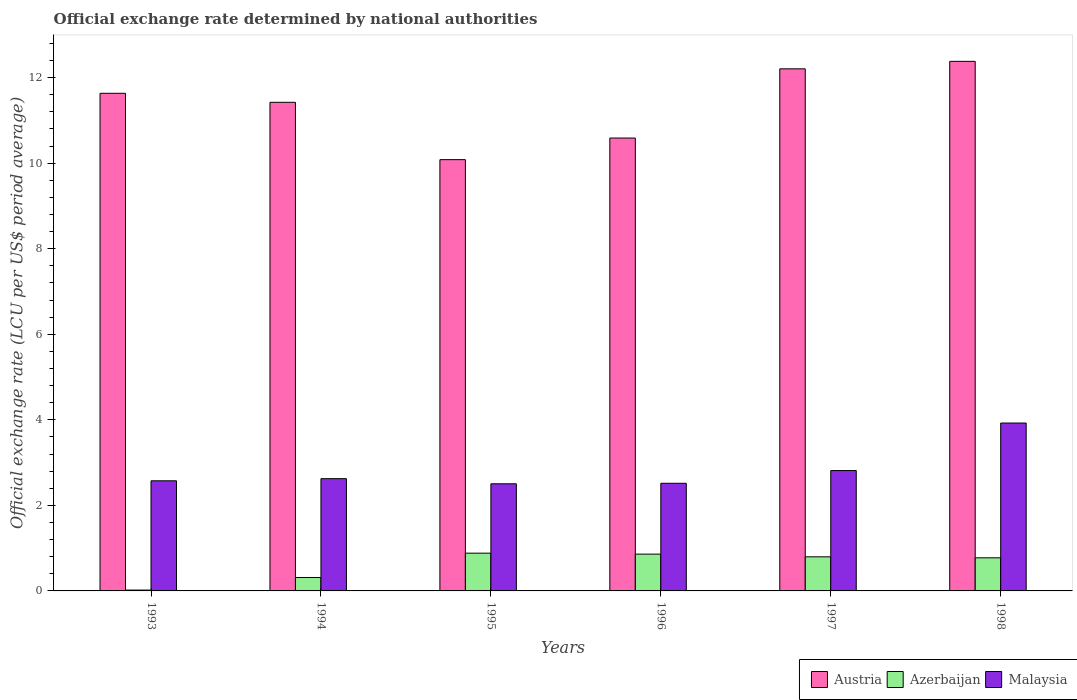How many bars are there on the 6th tick from the left?
Give a very brief answer. 3. What is the official exchange rate in Malaysia in 1997?
Keep it short and to the point. 2.81. Across all years, what is the maximum official exchange rate in Austria?
Your answer should be compact. 12.38. Across all years, what is the minimum official exchange rate in Malaysia?
Make the answer very short. 2.5. In which year was the official exchange rate in Austria maximum?
Your answer should be compact. 1998. What is the total official exchange rate in Azerbaijan in the graph?
Keep it short and to the point. 3.65. What is the difference between the official exchange rate in Malaysia in 1994 and that in 1996?
Give a very brief answer. 0.11. What is the difference between the official exchange rate in Austria in 1997 and the official exchange rate in Malaysia in 1996?
Your answer should be compact. 9.69. What is the average official exchange rate in Malaysia per year?
Your response must be concise. 2.83. In the year 1996, what is the difference between the official exchange rate in Azerbaijan and official exchange rate in Malaysia?
Ensure brevity in your answer.  -1.66. In how many years, is the official exchange rate in Austria greater than 8 LCU?
Make the answer very short. 6. What is the ratio of the official exchange rate in Austria in 1995 to that in 1997?
Ensure brevity in your answer.  0.83. What is the difference between the highest and the second highest official exchange rate in Azerbaijan?
Give a very brief answer. 0.02. What is the difference between the highest and the lowest official exchange rate in Austria?
Provide a succinct answer. 2.3. In how many years, is the official exchange rate in Malaysia greater than the average official exchange rate in Malaysia taken over all years?
Your response must be concise. 1. Is the sum of the official exchange rate in Austria in 1993 and 1998 greater than the maximum official exchange rate in Malaysia across all years?
Provide a succinct answer. Yes. What does the 2nd bar from the right in 1997 represents?
Keep it short and to the point. Azerbaijan. How many bars are there?
Give a very brief answer. 18. What is the difference between two consecutive major ticks on the Y-axis?
Your answer should be compact. 2. Are the values on the major ticks of Y-axis written in scientific E-notation?
Ensure brevity in your answer.  No. Does the graph contain grids?
Provide a short and direct response. No. Where does the legend appear in the graph?
Your response must be concise. Bottom right. How many legend labels are there?
Keep it short and to the point. 3. What is the title of the graph?
Your response must be concise. Official exchange rate determined by national authorities. Does "Switzerland" appear as one of the legend labels in the graph?
Give a very brief answer. No. What is the label or title of the X-axis?
Your answer should be very brief. Years. What is the label or title of the Y-axis?
Offer a very short reply. Official exchange rate (LCU per US$ period average). What is the Official exchange rate (LCU per US$ period average) in Austria in 1993?
Offer a terse response. 11.63. What is the Official exchange rate (LCU per US$ period average) in Azerbaijan in 1993?
Offer a terse response. 0.02. What is the Official exchange rate (LCU per US$ period average) in Malaysia in 1993?
Provide a succinct answer. 2.57. What is the Official exchange rate (LCU per US$ period average) in Austria in 1994?
Ensure brevity in your answer.  11.42. What is the Official exchange rate (LCU per US$ period average) of Azerbaijan in 1994?
Your response must be concise. 0.31. What is the Official exchange rate (LCU per US$ period average) in Malaysia in 1994?
Your answer should be very brief. 2.62. What is the Official exchange rate (LCU per US$ period average) in Austria in 1995?
Give a very brief answer. 10.08. What is the Official exchange rate (LCU per US$ period average) of Azerbaijan in 1995?
Your answer should be very brief. 0.88. What is the Official exchange rate (LCU per US$ period average) of Malaysia in 1995?
Give a very brief answer. 2.5. What is the Official exchange rate (LCU per US$ period average) in Austria in 1996?
Ensure brevity in your answer.  10.59. What is the Official exchange rate (LCU per US$ period average) in Azerbaijan in 1996?
Your response must be concise. 0.86. What is the Official exchange rate (LCU per US$ period average) in Malaysia in 1996?
Keep it short and to the point. 2.52. What is the Official exchange rate (LCU per US$ period average) of Austria in 1997?
Provide a short and direct response. 12.2. What is the Official exchange rate (LCU per US$ period average) in Azerbaijan in 1997?
Your answer should be compact. 0.8. What is the Official exchange rate (LCU per US$ period average) in Malaysia in 1997?
Provide a succinct answer. 2.81. What is the Official exchange rate (LCU per US$ period average) of Austria in 1998?
Offer a very short reply. 12.38. What is the Official exchange rate (LCU per US$ period average) in Azerbaijan in 1998?
Offer a terse response. 0.77. What is the Official exchange rate (LCU per US$ period average) in Malaysia in 1998?
Provide a succinct answer. 3.92. Across all years, what is the maximum Official exchange rate (LCU per US$ period average) in Austria?
Ensure brevity in your answer.  12.38. Across all years, what is the maximum Official exchange rate (LCU per US$ period average) in Azerbaijan?
Ensure brevity in your answer.  0.88. Across all years, what is the maximum Official exchange rate (LCU per US$ period average) in Malaysia?
Offer a terse response. 3.92. Across all years, what is the minimum Official exchange rate (LCU per US$ period average) in Austria?
Your response must be concise. 10.08. Across all years, what is the minimum Official exchange rate (LCU per US$ period average) of Azerbaijan?
Make the answer very short. 0.02. Across all years, what is the minimum Official exchange rate (LCU per US$ period average) in Malaysia?
Offer a terse response. 2.5. What is the total Official exchange rate (LCU per US$ period average) in Austria in the graph?
Ensure brevity in your answer.  68.31. What is the total Official exchange rate (LCU per US$ period average) in Azerbaijan in the graph?
Provide a short and direct response. 3.65. What is the total Official exchange rate (LCU per US$ period average) of Malaysia in the graph?
Your response must be concise. 16.96. What is the difference between the Official exchange rate (LCU per US$ period average) in Austria in 1993 and that in 1994?
Make the answer very short. 0.21. What is the difference between the Official exchange rate (LCU per US$ period average) in Azerbaijan in 1993 and that in 1994?
Your response must be concise. -0.29. What is the difference between the Official exchange rate (LCU per US$ period average) of Malaysia in 1993 and that in 1994?
Your answer should be very brief. -0.05. What is the difference between the Official exchange rate (LCU per US$ period average) of Austria in 1993 and that in 1995?
Provide a succinct answer. 1.55. What is the difference between the Official exchange rate (LCU per US$ period average) in Azerbaijan in 1993 and that in 1995?
Your response must be concise. -0.86. What is the difference between the Official exchange rate (LCU per US$ period average) of Malaysia in 1993 and that in 1995?
Your answer should be compact. 0.07. What is the difference between the Official exchange rate (LCU per US$ period average) of Austria in 1993 and that in 1996?
Provide a short and direct response. 1.05. What is the difference between the Official exchange rate (LCU per US$ period average) in Azerbaijan in 1993 and that in 1996?
Provide a succinct answer. -0.84. What is the difference between the Official exchange rate (LCU per US$ period average) in Malaysia in 1993 and that in 1996?
Provide a succinct answer. 0.06. What is the difference between the Official exchange rate (LCU per US$ period average) of Austria in 1993 and that in 1997?
Your answer should be compact. -0.57. What is the difference between the Official exchange rate (LCU per US$ period average) in Azerbaijan in 1993 and that in 1997?
Provide a succinct answer. -0.78. What is the difference between the Official exchange rate (LCU per US$ period average) in Malaysia in 1993 and that in 1997?
Ensure brevity in your answer.  -0.24. What is the difference between the Official exchange rate (LCU per US$ period average) of Austria in 1993 and that in 1998?
Your answer should be compact. -0.75. What is the difference between the Official exchange rate (LCU per US$ period average) in Azerbaijan in 1993 and that in 1998?
Your response must be concise. -0.75. What is the difference between the Official exchange rate (LCU per US$ period average) in Malaysia in 1993 and that in 1998?
Provide a short and direct response. -1.35. What is the difference between the Official exchange rate (LCU per US$ period average) of Austria in 1994 and that in 1995?
Your answer should be compact. 1.34. What is the difference between the Official exchange rate (LCU per US$ period average) in Azerbaijan in 1994 and that in 1995?
Your answer should be compact. -0.57. What is the difference between the Official exchange rate (LCU per US$ period average) in Malaysia in 1994 and that in 1995?
Your answer should be compact. 0.12. What is the difference between the Official exchange rate (LCU per US$ period average) in Austria in 1994 and that in 1996?
Your answer should be very brief. 0.84. What is the difference between the Official exchange rate (LCU per US$ period average) in Azerbaijan in 1994 and that in 1996?
Your response must be concise. -0.55. What is the difference between the Official exchange rate (LCU per US$ period average) of Malaysia in 1994 and that in 1996?
Your answer should be very brief. 0.11. What is the difference between the Official exchange rate (LCU per US$ period average) in Austria in 1994 and that in 1997?
Provide a succinct answer. -0.78. What is the difference between the Official exchange rate (LCU per US$ period average) in Azerbaijan in 1994 and that in 1997?
Offer a very short reply. -0.48. What is the difference between the Official exchange rate (LCU per US$ period average) in Malaysia in 1994 and that in 1997?
Ensure brevity in your answer.  -0.19. What is the difference between the Official exchange rate (LCU per US$ period average) in Austria in 1994 and that in 1998?
Offer a terse response. -0.96. What is the difference between the Official exchange rate (LCU per US$ period average) of Azerbaijan in 1994 and that in 1998?
Keep it short and to the point. -0.46. What is the difference between the Official exchange rate (LCU per US$ period average) in Malaysia in 1994 and that in 1998?
Make the answer very short. -1.3. What is the difference between the Official exchange rate (LCU per US$ period average) in Austria in 1995 and that in 1996?
Ensure brevity in your answer.  -0.51. What is the difference between the Official exchange rate (LCU per US$ period average) in Azerbaijan in 1995 and that in 1996?
Your response must be concise. 0.02. What is the difference between the Official exchange rate (LCU per US$ period average) in Malaysia in 1995 and that in 1996?
Provide a short and direct response. -0.01. What is the difference between the Official exchange rate (LCU per US$ period average) of Austria in 1995 and that in 1997?
Provide a short and direct response. -2.12. What is the difference between the Official exchange rate (LCU per US$ period average) of Azerbaijan in 1995 and that in 1997?
Offer a very short reply. 0.09. What is the difference between the Official exchange rate (LCU per US$ period average) of Malaysia in 1995 and that in 1997?
Provide a succinct answer. -0.31. What is the difference between the Official exchange rate (LCU per US$ period average) in Austria in 1995 and that in 1998?
Provide a succinct answer. -2.3. What is the difference between the Official exchange rate (LCU per US$ period average) of Azerbaijan in 1995 and that in 1998?
Your answer should be very brief. 0.11. What is the difference between the Official exchange rate (LCU per US$ period average) in Malaysia in 1995 and that in 1998?
Make the answer very short. -1.42. What is the difference between the Official exchange rate (LCU per US$ period average) of Austria in 1996 and that in 1997?
Provide a succinct answer. -1.62. What is the difference between the Official exchange rate (LCU per US$ period average) of Azerbaijan in 1996 and that in 1997?
Provide a succinct answer. 0.06. What is the difference between the Official exchange rate (LCU per US$ period average) in Malaysia in 1996 and that in 1997?
Your answer should be compact. -0.3. What is the difference between the Official exchange rate (LCU per US$ period average) in Austria in 1996 and that in 1998?
Your answer should be very brief. -1.79. What is the difference between the Official exchange rate (LCU per US$ period average) of Azerbaijan in 1996 and that in 1998?
Ensure brevity in your answer.  0.09. What is the difference between the Official exchange rate (LCU per US$ period average) of Malaysia in 1996 and that in 1998?
Offer a terse response. -1.41. What is the difference between the Official exchange rate (LCU per US$ period average) of Austria in 1997 and that in 1998?
Your answer should be compact. -0.17. What is the difference between the Official exchange rate (LCU per US$ period average) of Azerbaijan in 1997 and that in 1998?
Your answer should be very brief. 0.02. What is the difference between the Official exchange rate (LCU per US$ period average) in Malaysia in 1997 and that in 1998?
Provide a short and direct response. -1.11. What is the difference between the Official exchange rate (LCU per US$ period average) of Austria in 1993 and the Official exchange rate (LCU per US$ period average) of Azerbaijan in 1994?
Provide a succinct answer. 11.32. What is the difference between the Official exchange rate (LCU per US$ period average) in Austria in 1993 and the Official exchange rate (LCU per US$ period average) in Malaysia in 1994?
Keep it short and to the point. 9.01. What is the difference between the Official exchange rate (LCU per US$ period average) in Azerbaijan in 1993 and the Official exchange rate (LCU per US$ period average) in Malaysia in 1994?
Give a very brief answer. -2.6. What is the difference between the Official exchange rate (LCU per US$ period average) of Austria in 1993 and the Official exchange rate (LCU per US$ period average) of Azerbaijan in 1995?
Provide a succinct answer. 10.75. What is the difference between the Official exchange rate (LCU per US$ period average) of Austria in 1993 and the Official exchange rate (LCU per US$ period average) of Malaysia in 1995?
Provide a succinct answer. 9.13. What is the difference between the Official exchange rate (LCU per US$ period average) in Azerbaijan in 1993 and the Official exchange rate (LCU per US$ period average) in Malaysia in 1995?
Provide a succinct answer. -2.48. What is the difference between the Official exchange rate (LCU per US$ period average) of Austria in 1993 and the Official exchange rate (LCU per US$ period average) of Azerbaijan in 1996?
Provide a short and direct response. 10.77. What is the difference between the Official exchange rate (LCU per US$ period average) in Austria in 1993 and the Official exchange rate (LCU per US$ period average) in Malaysia in 1996?
Ensure brevity in your answer.  9.12. What is the difference between the Official exchange rate (LCU per US$ period average) in Azerbaijan in 1993 and the Official exchange rate (LCU per US$ period average) in Malaysia in 1996?
Your response must be concise. -2.5. What is the difference between the Official exchange rate (LCU per US$ period average) of Austria in 1993 and the Official exchange rate (LCU per US$ period average) of Azerbaijan in 1997?
Offer a terse response. 10.84. What is the difference between the Official exchange rate (LCU per US$ period average) in Austria in 1993 and the Official exchange rate (LCU per US$ period average) in Malaysia in 1997?
Your response must be concise. 8.82. What is the difference between the Official exchange rate (LCU per US$ period average) of Azerbaijan in 1993 and the Official exchange rate (LCU per US$ period average) of Malaysia in 1997?
Provide a short and direct response. -2.79. What is the difference between the Official exchange rate (LCU per US$ period average) of Austria in 1993 and the Official exchange rate (LCU per US$ period average) of Azerbaijan in 1998?
Make the answer very short. 10.86. What is the difference between the Official exchange rate (LCU per US$ period average) of Austria in 1993 and the Official exchange rate (LCU per US$ period average) of Malaysia in 1998?
Make the answer very short. 7.71. What is the difference between the Official exchange rate (LCU per US$ period average) in Azerbaijan in 1993 and the Official exchange rate (LCU per US$ period average) in Malaysia in 1998?
Offer a very short reply. -3.9. What is the difference between the Official exchange rate (LCU per US$ period average) in Austria in 1994 and the Official exchange rate (LCU per US$ period average) in Azerbaijan in 1995?
Your response must be concise. 10.54. What is the difference between the Official exchange rate (LCU per US$ period average) in Austria in 1994 and the Official exchange rate (LCU per US$ period average) in Malaysia in 1995?
Provide a short and direct response. 8.92. What is the difference between the Official exchange rate (LCU per US$ period average) of Azerbaijan in 1994 and the Official exchange rate (LCU per US$ period average) of Malaysia in 1995?
Provide a short and direct response. -2.19. What is the difference between the Official exchange rate (LCU per US$ period average) of Austria in 1994 and the Official exchange rate (LCU per US$ period average) of Azerbaijan in 1996?
Your response must be concise. 10.56. What is the difference between the Official exchange rate (LCU per US$ period average) of Austria in 1994 and the Official exchange rate (LCU per US$ period average) of Malaysia in 1996?
Keep it short and to the point. 8.91. What is the difference between the Official exchange rate (LCU per US$ period average) of Azerbaijan in 1994 and the Official exchange rate (LCU per US$ period average) of Malaysia in 1996?
Offer a terse response. -2.2. What is the difference between the Official exchange rate (LCU per US$ period average) in Austria in 1994 and the Official exchange rate (LCU per US$ period average) in Azerbaijan in 1997?
Give a very brief answer. 10.62. What is the difference between the Official exchange rate (LCU per US$ period average) in Austria in 1994 and the Official exchange rate (LCU per US$ period average) in Malaysia in 1997?
Make the answer very short. 8.61. What is the difference between the Official exchange rate (LCU per US$ period average) of Azerbaijan in 1994 and the Official exchange rate (LCU per US$ period average) of Malaysia in 1997?
Your response must be concise. -2.5. What is the difference between the Official exchange rate (LCU per US$ period average) of Austria in 1994 and the Official exchange rate (LCU per US$ period average) of Azerbaijan in 1998?
Your response must be concise. 10.65. What is the difference between the Official exchange rate (LCU per US$ period average) in Austria in 1994 and the Official exchange rate (LCU per US$ period average) in Malaysia in 1998?
Your answer should be very brief. 7.5. What is the difference between the Official exchange rate (LCU per US$ period average) in Azerbaijan in 1994 and the Official exchange rate (LCU per US$ period average) in Malaysia in 1998?
Provide a succinct answer. -3.61. What is the difference between the Official exchange rate (LCU per US$ period average) in Austria in 1995 and the Official exchange rate (LCU per US$ period average) in Azerbaijan in 1996?
Keep it short and to the point. 9.22. What is the difference between the Official exchange rate (LCU per US$ period average) in Austria in 1995 and the Official exchange rate (LCU per US$ period average) in Malaysia in 1996?
Your response must be concise. 7.57. What is the difference between the Official exchange rate (LCU per US$ period average) in Azerbaijan in 1995 and the Official exchange rate (LCU per US$ period average) in Malaysia in 1996?
Your response must be concise. -1.63. What is the difference between the Official exchange rate (LCU per US$ period average) in Austria in 1995 and the Official exchange rate (LCU per US$ period average) in Azerbaijan in 1997?
Keep it short and to the point. 9.28. What is the difference between the Official exchange rate (LCU per US$ period average) of Austria in 1995 and the Official exchange rate (LCU per US$ period average) of Malaysia in 1997?
Ensure brevity in your answer.  7.27. What is the difference between the Official exchange rate (LCU per US$ period average) of Azerbaijan in 1995 and the Official exchange rate (LCU per US$ period average) of Malaysia in 1997?
Provide a short and direct response. -1.93. What is the difference between the Official exchange rate (LCU per US$ period average) of Austria in 1995 and the Official exchange rate (LCU per US$ period average) of Azerbaijan in 1998?
Ensure brevity in your answer.  9.31. What is the difference between the Official exchange rate (LCU per US$ period average) in Austria in 1995 and the Official exchange rate (LCU per US$ period average) in Malaysia in 1998?
Make the answer very short. 6.16. What is the difference between the Official exchange rate (LCU per US$ period average) of Azerbaijan in 1995 and the Official exchange rate (LCU per US$ period average) of Malaysia in 1998?
Your answer should be very brief. -3.04. What is the difference between the Official exchange rate (LCU per US$ period average) of Austria in 1996 and the Official exchange rate (LCU per US$ period average) of Azerbaijan in 1997?
Offer a terse response. 9.79. What is the difference between the Official exchange rate (LCU per US$ period average) of Austria in 1996 and the Official exchange rate (LCU per US$ period average) of Malaysia in 1997?
Make the answer very short. 7.77. What is the difference between the Official exchange rate (LCU per US$ period average) of Azerbaijan in 1996 and the Official exchange rate (LCU per US$ period average) of Malaysia in 1997?
Ensure brevity in your answer.  -1.95. What is the difference between the Official exchange rate (LCU per US$ period average) of Austria in 1996 and the Official exchange rate (LCU per US$ period average) of Azerbaijan in 1998?
Your response must be concise. 9.81. What is the difference between the Official exchange rate (LCU per US$ period average) in Austria in 1996 and the Official exchange rate (LCU per US$ period average) in Malaysia in 1998?
Give a very brief answer. 6.66. What is the difference between the Official exchange rate (LCU per US$ period average) of Azerbaijan in 1996 and the Official exchange rate (LCU per US$ period average) of Malaysia in 1998?
Make the answer very short. -3.06. What is the difference between the Official exchange rate (LCU per US$ period average) in Austria in 1997 and the Official exchange rate (LCU per US$ period average) in Azerbaijan in 1998?
Offer a very short reply. 11.43. What is the difference between the Official exchange rate (LCU per US$ period average) in Austria in 1997 and the Official exchange rate (LCU per US$ period average) in Malaysia in 1998?
Offer a very short reply. 8.28. What is the difference between the Official exchange rate (LCU per US$ period average) of Azerbaijan in 1997 and the Official exchange rate (LCU per US$ period average) of Malaysia in 1998?
Give a very brief answer. -3.13. What is the average Official exchange rate (LCU per US$ period average) in Austria per year?
Give a very brief answer. 11.38. What is the average Official exchange rate (LCU per US$ period average) in Azerbaijan per year?
Provide a short and direct response. 0.61. What is the average Official exchange rate (LCU per US$ period average) of Malaysia per year?
Make the answer very short. 2.83. In the year 1993, what is the difference between the Official exchange rate (LCU per US$ period average) of Austria and Official exchange rate (LCU per US$ period average) of Azerbaijan?
Make the answer very short. 11.61. In the year 1993, what is the difference between the Official exchange rate (LCU per US$ period average) in Austria and Official exchange rate (LCU per US$ period average) in Malaysia?
Your answer should be compact. 9.06. In the year 1993, what is the difference between the Official exchange rate (LCU per US$ period average) of Azerbaijan and Official exchange rate (LCU per US$ period average) of Malaysia?
Provide a short and direct response. -2.55. In the year 1994, what is the difference between the Official exchange rate (LCU per US$ period average) of Austria and Official exchange rate (LCU per US$ period average) of Azerbaijan?
Offer a terse response. 11.11. In the year 1994, what is the difference between the Official exchange rate (LCU per US$ period average) in Austria and Official exchange rate (LCU per US$ period average) in Malaysia?
Keep it short and to the point. 8.8. In the year 1994, what is the difference between the Official exchange rate (LCU per US$ period average) of Azerbaijan and Official exchange rate (LCU per US$ period average) of Malaysia?
Ensure brevity in your answer.  -2.31. In the year 1995, what is the difference between the Official exchange rate (LCU per US$ period average) of Austria and Official exchange rate (LCU per US$ period average) of Azerbaijan?
Ensure brevity in your answer.  9.2. In the year 1995, what is the difference between the Official exchange rate (LCU per US$ period average) of Austria and Official exchange rate (LCU per US$ period average) of Malaysia?
Your response must be concise. 7.58. In the year 1995, what is the difference between the Official exchange rate (LCU per US$ period average) in Azerbaijan and Official exchange rate (LCU per US$ period average) in Malaysia?
Give a very brief answer. -1.62. In the year 1996, what is the difference between the Official exchange rate (LCU per US$ period average) in Austria and Official exchange rate (LCU per US$ period average) in Azerbaijan?
Give a very brief answer. 9.73. In the year 1996, what is the difference between the Official exchange rate (LCU per US$ period average) of Austria and Official exchange rate (LCU per US$ period average) of Malaysia?
Make the answer very short. 8.07. In the year 1996, what is the difference between the Official exchange rate (LCU per US$ period average) in Azerbaijan and Official exchange rate (LCU per US$ period average) in Malaysia?
Your answer should be very brief. -1.66. In the year 1997, what is the difference between the Official exchange rate (LCU per US$ period average) in Austria and Official exchange rate (LCU per US$ period average) in Azerbaijan?
Offer a very short reply. 11.41. In the year 1997, what is the difference between the Official exchange rate (LCU per US$ period average) in Austria and Official exchange rate (LCU per US$ period average) in Malaysia?
Ensure brevity in your answer.  9.39. In the year 1997, what is the difference between the Official exchange rate (LCU per US$ period average) in Azerbaijan and Official exchange rate (LCU per US$ period average) in Malaysia?
Ensure brevity in your answer.  -2.02. In the year 1998, what is the difference between the Official exchange rate (LCU per US$ period average) of Austria and Official exchange rate (LCU per US$ period average) of Azerbaijan?
Make the answer very short. 11.61. In the year 1998, what is the difference between the Official exchange rate (LCU per US$ period average) in Austria and Official exchange rate (LCU per US$ period average) in Malaysia?
Provide a short and direct response. 8.45. In the year 1998, what is the difference between the Official exchange rate (LCU per US$ period average) of Azerbaijan and Official exchange rate (LCU per US$ period average) of Malaysia?
Provide a short and direct response. -3.15. What is the ratio of the Official exchange rate (LCU per US$ period average) in Austria in 1993 to that in 1994?
Make the answer very short. 1.02. What is the ratio of the Official exchange rate (LCU per US$ period average) in Azerbaijan in 1993 to that in 1994?
Offer a terse response. 0.06. What is the ratio of the Official exchange rate (LCU per US$ period average) of Malaysia in 1993 to that in 1994?
Provide a short and direct response. 0.98. What is the ratio of the Official exchange rate (LCU per US$ period average) of Austria in 1993 to that in 1995?
Offer a very short reply. 1.15. What is the ratio of the Official exchange rate (LCU per US$ period average) in Azerbaijan in 1993 to that in 1995?
Your answer should be compact. 0.02. What is the ratio of the Official exchange rate (LCU per US$ period average) in Malaysia in 1993 to that in 1995?
Make the answer very short. 1.03. What is the ratio of the Official exchange rate (LCU per US$ period average) of Austria in 1993 to that in 1996?
Ensure brevity in your answer.  1.1. What is the ratio of the Official exchange rate (LCU per US$ period average) in Azerbaijan in 1993 to that in 1996?
Offer a terse response. 0.02. What is the ratio of the Official exchange rate (LCU per US$ period average) of Malaysia in 1993 to that in 1996?
Provide a succinct answer. 1.02. What is the ratio of the Official exchange rate (LCU per US$ period average) of Austria in 1993 to that in 1997?
Make the answer very short. 0.95. What is the ratio of the Official exchange rate (LCU per US$ period average) of Azerbaijan in 1993 to that in 1997?
Offer a terse response. 0.03. What is the ratio of the Official exchange rate (LCU per US$ period average) of Malaysia in 1993 to that in 1997?
Ensure brevity in your answer.  0.92. What is the ratio of the Official exchange rate (LCU per US$ period average) in Austria in 1993 to that in 1998?
Ensure brevity in your answer.  0.94. What is the ratio of the Official exchange rate (LCU per US$ period average) in Azerbaijan in 1993 to that in 1998?
Offer a terse response. 0.03. What is the ratio of the Official exchange rate (LCU per US$ period average) in Malaysia in 1993 to that in 1998?
Provide a short and direct response. 0.66. What is the ratio of the Official exchange rate (LCU per US$ period average) of Austria in 1994 to that in 1995?
Your answer should be very brief. 1.13. What is the ratio of the Official exchange rate (LCU per US$ period average) in Azerbaijan in 1994 to that in 1995?
Your response must be concise. 0.36. What is the ratio of the Official exchange rate (LCU per US$ period average) of Malaysia in 1994 to that in 1995?
Your answer should be very brief. 1.05. What is the ratio of the Official exchange rate (LCU per US$ period average) of Austria in 1994 to that in 1996?
Ensure brevity in your answer.  1.08. What is the ratio of the Official exchange rate (LCU per US$ period average) in Azerbaijan in 1994 to that in 1996?
Provide a succinct answer. 0.37. What is the ratio of the Official exchange rate (LCU per US$ period average) of Malaysia in 1994 to that in 1996?
Your response must be concise. 1.04. What is the ratio of the Official exchange rate (LCU per US$ period average) in Austria in 1994 to that in 1997?
Make the answer very short. 0.94. What is the ratio of the Official exchange rate (LCU per US$ period average) in Azerbaijan in 1994 to that in 1997?
Provide a succinct answer. 0.39. What is the ratio of the Official exchange rate (LCU per US$ period average) of Malaysia in 1994 to that in 1997?
Offer a terse response. 0.93. What is the ratio of the Official exchange rate (LCU per US$ period average) of Austria in 1994 to that in 1998?
Your response must be concise. 0.92. What is the ratio of the Official exchange rate (LCU per US$ period average) of Azerbaijan in 1994 to that in 1998?
Ensure brevity in your answer.  0.41. What is the ratio of the Official exchange rate (LCU per US$ period average) of Malaysia in 1994 to that in 1998?
Make the answer very short. 0.67. What is the ratio of the Official exchange rate (LCU per US$ period average) of Austria in 1995 to that in 1996?
Provide a succinct answer. 0.95. What is the ratio of the Official exchange rate (LCU per US$ period average) in Azerbaijan in 1995 to that in 1996?
Your answer should be compact. 1.03. What is the ratio of the Official exchange rate (LCU per US$ period average) in Austria in 1995 to that in 1997?
Ensure brevity in your answer.  0.83. What is the ratio of the Official exchange rate (LCU per US$ period average) in Azerbaijan in 1995 to that in 1997?
Make the answer very short. 1.11. What is the ratio of the Official exchange rate (LCU per US$ period average) in Malaysia in 1995 to that in 1997?
Provide a short and direct response. 0.89. What is the ratio of the Official exchange rate (LCU per US$ period average) in Austria in 1995 to that in 1998?
Provide a succinct answer. 0.81. What is the ratio of the Official exchange rate (LCU per US$ period average) of Azerbaijan in 1995 to that in 1998?
Ensure brevity in your answer.  1.14. What is the ratio of the Official exchange rate (LCU per US$ period average) of Malaysia in 1995 to that in 1998?
Give a very brief answer. 0.64. What is the ratio of the Official exchange rate (LCU per US$ period average) in Austria in 1996 to that in 1997?
Your answer should be compact. 0.87. What is the ratio of the Official exchange rate (LCU per US$ period average) in Azerbaijan in 1996 to that in 1997?
Make the answer very short. 1.08. What is the ratio of the Official exchange rate (LCU per US$ period average) in Malaysia in 1996 to that in 1997?
Your answer should be compact. 0.89. What is the ratio of the Official exchange rate (LCU per US$ period average) in Austria in 1996 to that in 1998?
Keep it short and to the point. 0.86. What is the ratio of the Official exchange rate (LCU per US$ period average) in Azerbaijan in 1996 to that in 1998?
Give a very brief answer. 1.11. What is the ratio of the Official exchange rate (LCU per US$ period average) in Malaysia in 1996 to that in 1998?
Give a very brief answer. 0.64. What is the ratio of the Official exchange rate (LCU per US$ period average) of Austria in 1997 to that in 1998?
Your response must be concise. 0.99. What is the ratio of the Official exchange rate (LCU per US$ period average) of Azerbaijan in 1997 to that in 1998?
Your response must be concise. 1.03. What is the ratio of the Official exchange rate (LCU per US$ period average) of Malaysia in 1997 to that in 1998?
Your answer should be very brief. 0.72. What is the difference between the highest and the second highest Official exchange rate (LCU per US$ period average) of Austria?
Provide a succinct answer. 0.17. What is the difference between the highest and the second highest Official exchange rate (LCU per US$ period average) of Azerbaijan?
Ensure brevity in your answer.  0.02. What is the difference between the highest and the second highest Official exchange rate (LCU per US$ period average) of Malaysia?
Make the answer very short. 1.11. What is the difference between the highest and the lowest Official exchange rate (LCU per US$ period average) in Austria?
Make the answer very short. 2.3. What is the difference between the highest and the lowest Official exchange rate (LCU per US$ period average) of Azerbaijan?
Provide a succinct answer. 0.86. What is the difference between the highest and the lowest Official exchange rate (LCU per US$ period average) in Malaysia?
Your answer should be very brief. 1.42. 